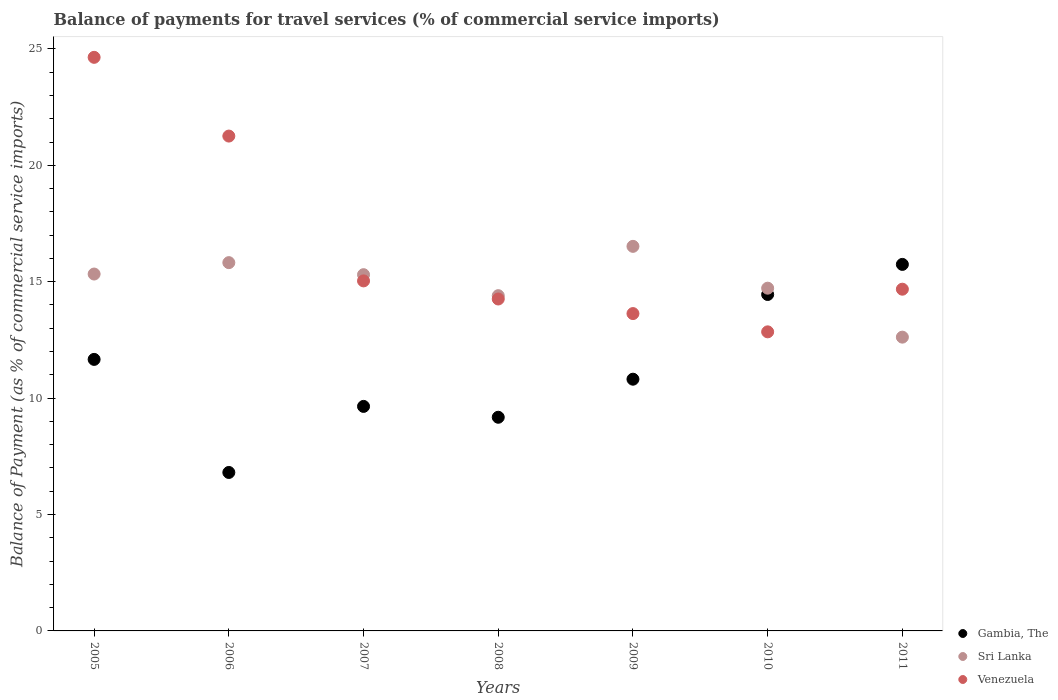Is the number of dotlines equal to the number of legend labels?
Keep it short and to the point. Yes. What is the balance of payments for travel services in Gambia, The in 2007?
Your response must be concise. 9.64. Across all years, what is the maximum balance of payments for travel services in Gambia, The?
Offer a very short reply. 15.74. Across all years, what is the minimum balance of payments for travel services in Venezuela?
Keep it short and to the point. 12.85. In which year was the balance of payments for travel services in Gambia, The maximum?
Ensure brevity in your answer.  2011. What is the total balance of payments for travel services in Venezuela in the graph?
Offer a terse response. 116.34. What is the difference between the balance of payments for travel services in Sri Lanka in 2008 and that in 2009?
Your answer should be compact. -2.12. What is the difference between the balance of payments for travel services in Gambia, The in 2006 and the balance of payments for travel services in Sri Lanka in 2010?
Your answer should be very brief. -7.92. What is the average balance of payments for travel services in Gambia, The per year?
Provide a short and direct response. 11.19. In the year 2008, what is the difference between the balance of payments for travel services in Gambia, The and balance of payments for travel services in Sri Lanka?
Keep it short and to the point. -5.22. What is the ratio of the balance of payments for travel services in Venezuela in 2007 to that in 2011?
Your response must be concise. 1.02. Is the balance of payments for travel services in Sri Lanka in 2005 less than that in 2009?
Offer a very short reply. Yes. Is the difference between the balance of payments for travel services in Gambia, The in 2007 and 2009 greater than the difference between the balance of payments for travel services in Sri Lanka in 2007 and 2009?
Your answer should be very brief. Yes. What is the difference between the highest and the second highest balance of payments for travel services in Gambia, The?
Ensure brevity in your answer.  1.29. What is the difference between the highest and the lowest balance of payments for travel services in Gambia, The?
Make the answer very short. 8.94. Does the balance of payments for travel services in Gambia, The monotonically increase over the years?
Keep it short and to the point. No. Is the balance of payments for travel services in Sri Lanka strictly greater than the balance of payments for travel services in Gambia, The over the years?
Keep it short and to the point. No. How many dotlines are there?
Your answer should be compact. 3. Does the graph contain grids?
Give a very brief answer. No. How many legend labels are there?
Offer a very short reply. 3. How are the legend labels stacked?
Give a very brief answer. Vertical. What is the title of the graph?
Provide a short and direct response. Balance of payments for travel services (% of commercial service imports). What is the label or title of the X-axis?
Your response must be concise. Years. What is the label or title of the Y-axis?
Offer a terse response. Balance of Payment (as % of commercial service imports). What is the Balance of Payment (as % of commercial service imports) in Gambia, The in 2005?
Give a very brief answer. 11.66. What is the Balance of Payment (as % of commercial service imports) in Sri Lanka in 2005?
Keep it short and to the point. 15.33. What is the Balance of Payment (as % of commercial service imports) of Venezuela in 2005?
Your answer should be compact. 24.64. What is the Balance of Payment (as % of commercial service imports) of Gambia, The in 2006?
Your answer should be compact. 6.81. What is the Balance of Payment (as % of commercial service imports) of Sri Lanka in 2006?
Offer a terse response. 15.82. What is the Balance of Payment (as % of commercial service imports) of Venezuela in 2006?
Give a very brief answer. 21.26. What is the Balance of Payment (as % of commercial service imports) in Gambia, The in 2007?
Your response must be concise. 9.64. What is the Balance of Payment (as % of commercial service imports) of Sri Lanka in 2007?
Your response must be concise. 15.3. What is the Balance of Payment (as % of commercial service imports) of Venezuela in 2007?
Give a very brief answer. 15.04. What is the Balance of Payment (as % of commercial service imports) in Gambia, The in 2008?
Keep it short and to the point. 9.18. What is the Balance of Payment (as % of commercial service imports) in Sri Lanka in 2008?
Make the answer very short. 14.4. What is the Balance of Payment (as % of commercial service imports) of Venezuela in 2008?
Your answer should be compact. 14.26. What is the Balance of Payment (as % of commercial service imports) of Gambia, The in 2009?
Your answer should be very brief. 10.81. What is the Balance of Payment (as % of commercial service imports) in Sri Lanka in 2009?
Offer a terse response. 16.52. What is the Balance of Payment (as % of commercial service imports) of Venezuela in 2009?
Your response must be concise. 13.63. What is the Balance of Payment (as % of commercial service imports) in Gambia, The in 2010?
Make the answer very short. 14.45. What is the Balance of Payment (as % of commercial service imports) in Sri Lanka in 2010?
Keep it short and to the point. 14.72. What is the Balance of Payment (as % of commercial service imports) in Venezuela in 2010?
Provide a succinct answer. 12.85. What is the Balance of Payment (as % of commercial service imports) of Gambia, The in 2011?
Make the answer very short. 15.74. What is the Balance of Payment (as % of commercial service imports) in Sri Lanka in 2011?
Your answer should be compact. 12.62. What is the Balance of Payment (as % of commercial service imports) of Venezuela in 2011?
Make the answer very short. 14.68. Across all years, what is the maximum Balance of Payment (as % of commercial service imports) in Gambia, The?
Provide a short and direct response. 15.74. Across all years, what is the maximum Balance of Payment (as % of commercial service imports) of Sri Lanka?
Your answer should be very brief. 16.52. Across all years, what is the maximum Balance of Payment (as % of commercial service imports) of Venezuela?
Your answer should be very brief. 24.64. Across all years, what is the minimum Balance of Payment (as % of commercial service imports) of Gambia, The?
Ensure brevity in your answer.  6.81. Across all years, what is the minimum Balance of Payment (as % of commercial service imports) of Sri Lanka?
Keep it short and to the point. 12.62. Across all years, what is the minimum Balance of Payment (as % of commercial service imports) in Venezuela?
Make the answer very short. 12.85. What is the total Balance of Payment (as % of commercial service imports) in Gambia, The in the graph?
Offer a terse response. 78.3. What is the total Balance of Payment (as % of commercial service imports) in Sri Lanka in the graph?
Offer a terse response. 104.71. What is the total Balance of Payment (as % of commercial service imports) in Venezuela in the graph?
Give a very brief answer. 116.34. What is the difference between the Balance of Payment (as % of commercial service imports) in Gambia, The in 2005 and that in 2006?
Provide a short and direct response. 4.86. What is the difference between the Balance of Payment (as % of commercial service imports) of Sri Lanka in 2005 and that in 2006?
Provide a short and direct response. -0.49. What is the difference between the Balance of Payment (as % of commercial service imports) of Venezuela in 2005 and that in 2006?
Your response must be concise. 3.38. What is the difference between the Balance of Payment (as % of commercial service imports) of Gambia, The in 2005 and that in 2007?
Make the answer very short. 2.02. What is the difference between the Balance of Payment (as % of commercial service imports) in Sri Lanka in 2005 and that in 2007?
Give a very brief answer. 0.03. What is the difference between the Balance of Payment (as % of commercial service imports) of Venezuela in 2005 and that in 2007?
Your answer should be very brief. 9.6. What is the difference between the Balance of Payment (as % of commercial service imports) of Gambia, The in 2005 and that in 2008?
Keep it short and to the point. 2.49. What is the difference between the Balance of Payment (as % of commercial service imports) in Sri Lanka in 2005 and that in 2008?
Your answer should be compact. 0.93. What is the difference between the Balance of Payment (as % of commercial service imports) in Venezuela in 2005 and that in 2008?
Make the answer very short. 10.38. What is the difference between the Balance of Payment (as % of commercial service imports) in Gambia, The in 2005 and that in 2009?
Offer a very short reply. 0.85. What is the difference between the Balance of Payment (as % of commercial service imports) of Sri Lanka in 2005 and that in 2009?
Your response must be concise. -1.19. What is the difference between the Balance of Payment (as % of commercial service imports) in Venezuela in 2005 and that in 2009?
Your answer should be compact. 11.01. What is the difference between the Balance of Payment (as % of commercial service imports) in Gambia, The in 2005 and that in 2010?
Provide a succinct answer. -2.79. What is the difference between the Balance of Payment (as % of commercial service imports) in Sri Lanka in 2005 and that in 2010?
Give a very brief answer. 0.61. What is the difference between the Balance of Payment (as % of commercial service imports) in Venezuela in 2005 and that in 2010?
Give a very brief answer. 11.79. What is the difference between the Balance of Payment (as % of commercial service imports) in Gambia, The in 2005 and that in 2011?
Ensure brevity in your answer.  -4.08. What is the difference between the Balance of Payment (as % of commercial service imports) in Sri Lanka in 2005 and that in 2011?
Ensure brevity in your answer.  2.71. What is the difference between the Balance of Payment (as % of commercial service imports) of Venezuela in 2005 and that in 2011?
Provide a succinct answer. 9.96. What is the difference between the Balance of Payment (as % of commercial service imports) in Gambia, The in 2006 and that in 2007?
Your answer should be compact. -2.84. What is the difference between the Balance of Payment (as % of commercial service imports) in Sri Lanka in 2006 and that in 2007?
Make the answer very short. 0.52. What is the difference between the Balance of Payment (as % of commercial service imports) of Venezuela in 2006 and that in 2007?
Offer a very short reply. 6.22. What is the difference between the Balance of Payment (as % of commercial service imports) of Gambia, The in 2006 and that in 2008?
Your answer should be compact. -2.37. What is the difference between the Balance of Payment (as % of commercial service imports) in Sri Lanka in 2006 and that in 2008?
Offer a very short reply. 1.42. What is the difference between the Balance of Payment (as % of commercial service imports) of Venezuela in 2006 and that in 2008?
Provide a succinct answer. 7. What is the difference between the Balance of Payment (as % of commercial service imports) in Gambia, The in 2006 and that in 2009?
Keep it short and to the point. -4.01. What is the difference between the Balance of Payment (as % of commercial service imports) in Sri Lanka in 2006 and that in 2009?
Ensure brevity in your answer.  -0.7. What is the difference between the Balance of Payment (as % of commercial service imports) of Venezuela in 2006 and that in 2009?
Your answer should be compact. 7.62. What is the difference between the Balance of Payment (as % of commercial service imports) in Gambia, The in 2006 and that in 2010?
Ensure brevity in your answer.  -7.64. What is the difference between the Balance of Payment (as % of commercial service imports) of Sri Lanka in 2006 and that in 2010?
Your answer should be compact. 1.1. What is the difference between the Balance of Payment (as % of commercial service imports) in Venezuela in 2006 and that in 2010?
Give a very brief answer. 8.41. What is the difference between the Balance of Payment (as % of commercial service imports) in Gambia, The in 2006 and that in 2011?
Ensure brevity in your answer.  -8.94. What is the difference between the Balance of Payment (as % of commercial service imports) in Sri Lanka in 2006 and that in 2011?
Your answer should be compact. 3.2. What is the difference between the Balance of Payment (as % of commercial service imports) in Venezuela in 2006 and that in 2011?
Keep it short and to the point. 6.58. What is the difference between the Balance of Payment (as % of commercial service imports) of Gambia, The in 2007 and that in 2008?
Ensure brevity in your answer.  0.47. What is the difference between the Balance of Payment (as % of commercial service imports) in Sri Lanka in 2007 and that in 2008?
Your answer should be very brief. 0.9. What is the difference between the Balance of Payment (as % of commercial service imports) in Venezuela in 2007 and that in 2008?
Provide a short and direct response. 0.78. What is the difference between the Balance of Payment (as % of commercial service imports) of Gambia, The in 2007 and that in 2009?
Give a very brief answer. -1.17. What is the difference between the Balance of Payment (as % of commercial service imports) of Sri Lanka in 2007 and that in 2009?
Give a very brief answer. -1.22. What is the difference between the Balance of Payment (as % of commercial service imports) of Venezuela in 2007 and that in 2009?
Provide a short and direct response. 1.4. What is the difference between the Balance of Payment (as % of commercial service imports) in Gambia, The in 2007 and that in 2010?
Your answer should be compact. -4.81. What is the difference between the Balance of Payment (as % of commercial service imports) of Sri Lanka in 2007 and that in 2010?
Offer a very short reply. 0.58. What is the difference between the Balance of Payment (as % of commercial service imports) of Venezuela in 2007 and that in 2010?
Offer a very short reply. 2.19. What is the difference between the Balance of Payment (as % of commercial service imports) of Gambia, The in 2007 and that in 2011?
Make the answer very short. -6.1. What is the difference between the Balance of Payment (as % of commercial service imports) in Sri Lanka in 2007 and that in 2011?
Provide a short and direct response. 2.68. What is the difference between the Balance of Payment (as % of commercial service imports) of Venezuela in 2007 and that in 2011?
Offer a very short reply. 0.36. What is the difference between the Balance of Payment (as % of commercial service imports) in Gambia, The in 2008 and that in 2009?
Offer a terse response. -1.64. What is the difference between the Balance of Payment (as % of commercial service imports) of Sri Lanka in 2008 and that in 2009?
Make the answer very short. -2.12. What is the difference between the Balance of Payment (as % of commercial service imports) in Venezuela in 2008 and that in 2009?
Give a very brief answer. 0.63. What is the difference between the Balance of Payment (as % of commercial service imports) in Gambia, The in 2008 and that in 2010?
Your response must be concise. -5.27. What is the difference between the Balance of Payment (as % of commercial service imports) in Sri Lanka in 2008 and that in 2010?
Provide a short and direct response. -0.32. What is the difference between the Balance of Payment (as % of commercial service imports) in Venezuela in 2008 and that in 2010?
Provide a short and direct response. 1.41. What is the difference between the Balance of Payment (as % of commercial service imports) in Gambia, The in 2008 and that in 2011?
Your response must be concise. -6.57. What is the difference between the Balance of Payment (as % of commercial service imports) of Sri Lanka in 2008 and that in 2011?
Your answer should be very brief. 1.78. What is the difference between the Balance of Payment (as % of commercial service imports) in Venezuela in 2008 and that in 2011?
Give a very brief answer. -0.42. What is the difference between the Balance of Payment (as % of commercial service imports) in Gambia, The in 2009 and that in 2010?
Make the answer very short. -3.64. What is the difference between the Balance of Payment (as % of commercial service imports) in Sri Lanka in 2009 and that in 2010?
Your answer should be very brief. 1.8. What is the difference between the Balance of Payment (as % of commercial service imports) of Venezuela in 2009 and that in 2010?
Provide a short and direct response. 0.78. What is the difference between the Balance of Payment (as % of commercial service imports) of Gambia, The in 2009 and that in 2011?
Keep it short and to the point. -4.93. What is the difference between the Balance of Payment (as % of commercial service imports) in Sri Lanka in 2009 and that in 2011?
Make the answer very short. 3.9. What is the difference between the Balance of Payment (as % of commercial service imports) of Venezuela in 2009 and that in 2011?
Offer a terse response. -1.05. What is the difference between the Balance of Payment (as % of commercial service imports) of Gambia, The in 2010 and that in 2011?
Your answer should be compact. -1.29. What is the difference between the Balance of Payment (as % of commercial service imports) of Sri Lanka in 2010 and that in 2011?
Offer a terse response. 2.1. What is the difference between the Balance of Payment (as % of commercial service imports) of Venezuela in 2010 and that in 2011?
Keep it short and to the point. -1.83. What is the difference between the Balance of Payment (as % of commercial service imports) in Gambia, The in 2005 and the Balance of Payment (as % of commercial service imports) in Sri Lanka in 2006?
Keep it short and to the point. -4.16. What is the difference between the Balance of Payment (as % of commercial service imports) in Gambia, The in 2005 and the Balance of Payment (as % of commercial service imports) in Venezuela in 2006?
Offer a very short reply. -9.59. What is the difference between the Balance of Payment (as % of commercial service imports) in Sri Lanka in 2005 and the Balance of Payment (as % of commercial service imports) in Venezuela in 2006?
Ensure brevity in your answer.  -5.93. What is the difference between the Balance of Payment (as % of commercial service imports) of Gambia, The in 2005 and the Balance of Payment (as % of commercial service imports) of Sri Lanka in 2007?
Your answer should be compact. -3.64. What is the difference between the Balance of Payment (as % of commercial service imports) of Gambia, The in 2005 and the Balance of Payment (as % of commercial service imports) of Venezuela in 2007?
Your response must be concise. -3.37. What is the difference between the Balance of Payment (as % of commercial service imports) of Sri Lanka in 2005 and the Balance of Payment (as % of commercial service imports) of Venezuela in 2007?
Provide a short and direct response. 0.29. What is the difference between the Balance of Payment (as % of commercial service imports) of Gambia, The in 2005 and the Balance of Payment (as % of commercial service imports) of Sri Lanka in 2008?
Your response must be concise. -2.74. What is the difference between the Balance of Payment (as % of commercial service imports) in Gambia, The in 2005 and the Balance of Payment (as % of commercial service imports) in Venezuela in 2008?
Give a very brief answer. -2.59. What is the difference between the Balance of Payment (as % of commercial service imports) of Sri Lanka in 2005 and the Balance of Payment (as % of commercial service imports) of Venezuela in 2008?
Your answer should be compact. 1.07. What is the difference between the Balance of Payment (as % of commercial service imports) in Gambia, The in 2005 and the Balance of Payment (as % of commercial service imports) in Sri Lanka in 2009?
Your answer should be compact. -4.86. What is the difference between the Balance of Payment (as % of commercial service imports) in Gambia, The in 2005 and the Balance of Payment (as % of commercial service imports) in Venezuela in 2009?
Keep it short and to the point. -1.97. What is the difference between the Balance of Payment (as % of commercial service imports) of Sri Lanka in 2005 and the Balance of Payment (as % of commercial service imports) of Venezuela in 2009?
Give a very brief answer. 1.7. What is the difference between the Balance of Payment (as % of commercial service imports) of Gambia, The in 2005 and the Balance of Payment (as % of commercial service imports) of Sri Lanka in 2010?
Make the answer very short. -3.06. What is the difference between the Balance of Payment (as % of commercial service imports) of Gambia, The in 2005 and the Balance of Payment (as % of commercial service imports) of Venezuela in 2010?
Provide a short and direct response. -1.18. What is the difference between the Balance of Payment (as % of commercial service imports) in Sri Lanka in 2005 and the Balance of Payment (as % of commercial service imports) in Venezuela in 2010?
Make the answer very short. 2.48. What is the difference between the Balance of Payment (as % of commercial service imports) in Gambia, The in 2005 and the Balance of Payment (as % of commercial service imports) in Sri Lanka in 2011?
Give a very brief answer. -0.96. What is the difference between the Balance of Payment (as % of commercial service imports) of Gambia, The in 2005 and the Balance of Payment (as % of commercial service imports) of Venezuela in 2011?
Give a very brief answer. -3.02. What is the difference between the Balance of Payment (as % of commercial service imports) in Sri Lanka in 2005 and the Balance of Payment (as % of commercial service imports) in Venezuela in 2011?
Keep it short and to the point. 0.65. What is the difference between the Balance of Payment (as % of commercial service imports) of Gambia, The in 2006 and the Balance of Payment (as % of commercial service imports) of Sri Lanka in 2007?
Give a very brief answer. -8.5. What is the difference between the Balance of Payment (as % of commercial service imports) of Gambia, The in 2006 and the Balance of Payment (as % of commercial service imports) of Venezuela in 2007?
Provide a succinct answer. -8.23. What is the difference between the Balance of Payment (as % of commercial service imports) in Sri Lanka in 2006 and the Balance of Payment (as % of commercial service imports) in Venezuela in 2007?
Offer a very short reply. 0.78. What is the difference between the Balance of Payment (as % of commercial service imports) of Gambia, The in 2006 and the Balance of Payment (as % of commercial service imports) of Sri Lanka in 2008?
Make the answer very short. -7.59. What is the difference between the Balance of Payment (as % of commercial service imports) of Gambia, The in 2006 and the Balance of Payment (as % of commercial service imports) of Venezuela in 2008?
Offer a very short reply. -7.45. What is the difference between the Balance of Payment (as % of commercial service imports) of Sri Lanka in 2006 and the Balance of Payment (as % of commercial service imports) of Venezuela in 2008?
Your answer should be compact. 1.56. What is the difference between the Balance of Payment (as % of commercial service imports) in Gambia, The in 2006 and the Balance of Payment (as % of commercial service imports) in Sri Lanka in 2009?
Your answer should be very brief. -9.71. What is the difference between the Balance of Payment (as % of commercial service imports) in Gambia, The in 2006 and the Balance of Payment (as % of commercial service imports) in Venezuela in 2009?
Your response must be concise. -6.82. What is the difference between the Balance of Payment (as % of commercial service imports) in Sri Lanka in 2006 and the Balance of Payment (as % of commercial service imports) in Venezuela in 2009?
Your answer should be compact. 2.19. What is the difference between the Balance of Payment (as % of commercial service imports) of Gambia, The in 2006 and the Balance of Payment (as % of commercial service imports) of Sri Lanka in 2010?
Offer a very short reply. -7.92. What is the difference between the Balance of Payment (as % of commercial service imports) in Gambia, The in 2006 and the Balance of Payment (as % of commercial service imports) in Venezuela in 2010?
Your response must be concise. -6.04. What is the difference between the Balance of Payment (as % of commercial service imports) of Sri Lanka in 2006 and the Balance of Payment (as % of commercial service imports) of Venezuela in 2010?
Keep it short and to the point. 2.97. What is the difference between the Balance of Payment (as % of commercial service imports) in Gambia, The in 2006 and the Balance of Payment (as % of commercial service imports) in Sri Lanka in 2011?
Make the answer very short. -5.81. What is the difference between the Balance of Payment (as % of commercial service imports) of Gambia, The in 2006 and the Balance of Payment (as % of commercial service imports) of Venezuela in 2011?
Keep it short and to the point. -7.87. What is the difference between the Balance of Payment (as % of commercial service imports) of Sri Lanka in 2006 and the Balance of Payment (as % of commercial service imports) of Venezuela in 2011?
Make the answer very short. 1.14. What is the difference between the Balance of Payment (as % of commercial service imports) in Gambia, The in 2007 and the Balance of Payment (as % of commercial service imports) in Sri Lanka in 2008?
Keep it short and to the point. -4.76. What is the difference between the Balance of Payment (as % of commercial service imports) of Gambia, The in 2007 and the Balance of Payment (as % of commercial service imports) of Venezuela in 2008?
Your answer should be compact. -4.61. What is the difference between the Balance of Payment (as % of commercial service imports) of Sri Lanka in 2007 and the Balance of Payment (as % of commercial service imports) of Venezuela in 2008?
Make the answer very short. 1.04. What is the difference between the Balance of Payment (as % of commercial service imports) in Gambia, The in 2007 and the Balance of Payment (as % of commercial service imports) in Sri Lanka in 2009?
Provide a short and direct response. -6.87. What is the difference between the Balance of Payment (as % of commercial service imports) of Gambia, The in 2007 and the Balance of Payment (as % of commercial service imports) of Venezuela in 2009?
Your response must be concise. -3.99. What is the difference between the Balance of Payment (as % of commercial service imports) of Sri Lanka in 2007 and the Balance of Payment (as % of commercial service imports) of Venezuela in 2009?
Your answer should be compact. 1.67. What is the difference between the Balance of Payment (as % of commercial service imports) of Gambia, The in 2007 and the Balance of Payment (as % of commercial service imports) of Sri Lanka in 2010?
Your response must be concise. -5.08. What is the difference between the Balance of Payment (as % of commercial service imports) of Gambia, The in 2007 and the Balance of Payment (as % of commercial service imports) of Venezuela in 2010?
Your response must be concise. -3.2. What is the difference between the Balance of Payment (as % of commercial service imports) in Sri Lanka in 2007 and the Balance of Payment (as % of commercial service imports) in Venezuela in 2010?
Your answer should be compact. 2.46. What is the difference between the Balance of Payment (as % of commercial service imports) of Gambia, The in 2007 and the Balance of Payment (as % of commercial service imports) of Sri Lanka in 2011?
Give a very brief answer. -2.97. What is the difference between the Balance of Payment (as % of commercial service imports) in Gambia, The in 2007 and the Balance of Payment (as % of commercial service imports) in Venezuela in 2011?
Your answer should be compact. -5.03. What is the difference between the Balance of Payment (as % of commercial service imports) of Sri Lanka in 2007 and the Balance of Payment (as % of commercial service imports) of Venezuela in 2011?
Ensure brevity in your answer.  0.62. What is the difference between the Balance of Payment (as % of commercial service imports) in Gambia, The in 2008 and the Balance of Payment (as % of commercial service imports) in Sri Lanka in 2009?
Your answer should be compact. -7.34. What is the difference between the Balance of Payment (as % of commercial service imports) in Gambia, The in 2008 and the Balance of Payment (as % of commercial service imports) in Venezuela in 2009?
Offer a terse response. -4.45. What is the difference between the Balance of Payment (as % of commercial service imports) of Sri Lanka in 2008 and the Balance of Payment (as % of commercial service imports) of Venezuela in 2009?
Ensure brevity in your answer.  0.77. What is the difference between the Balance of Payment (as % of commercial service imports) of Gambia, The in 2008 and the Balance of Payment (as % of commercial service imports) of Sri Lanka in 2010?
Offer a very short reply. -5.54. What is the difference between the Balance of Payment (as % of commercial service imports) in Gambia, The in 2008 and the Balance of Payment (as % of commercial service imports) in Venezuela in 2010?
Ensure brevity in your answer.  -3.67. What is the difference between the Balance of Payment (as % of commercial service imports) in Sri Lanka in 2008 and the Balance of Payment (as % of commercial service imports) in Venezuela in 2010?
Your response must be concise. 1.55. What is the difference between the Balance of Payment (as % of commercial service imports) in Gambia, The in 2008 and the Balance of Payment (as % of commercial service imports) in Sri Lanka in 2011?
Provide a short and direct response. -3.44. What is the difference between the Balance of Payment (as % of commercial service imports) in Gambia, The in 2008 and the Balance of Payment (as % of commercial service imports) in Venezuela in 2011?
Provide a short and direct response. -5.5. What is the difference between the Balance of Payment (as % of commercial service imports) in Sri Lanka in 2008 and the Balance of Payment (as % of commercial service imports) in Venezuela in 2011?
Offer a very short reply. -0.28. What is the difference between the Balance of Payment (as % of commercial service imports) of Gambia, The in 2009 and the Balance of Payment (as % of commercial service imports) of Sri Lanka in 2010?
Provide a succinct answer. -3.91. What is the difference between the Balance of Payment (as % of commercial service imports) in Gambia, The in 2009 and the Balance of Payment (as % of commercial service imports) in Venezuela in 2010?
Offer a very short reply. -2.03. What is the difference between the Balance of Payment (as % of commercial service imports) of Sri Lanka in 2009 and the Balance of Payment (as % of commercial service imports) of Venezuela in 2010?
Your response must be concise. 3.67. What is the difference between the Balance of Payment (as % of commercial service imports) in Gambia, The in 2009 and the Balance of Payment (as % of commercial service imports) in Sri Lanka in 2011?
Your answer should be compact. -1.81. What is the difference between the Balance of Payment (as % of commercial service imports) in Gambia, The in 2009 and the Balance of Payment (as % of commercial service imports) in Venezuela in 2011?
Ensure brevity in your answer.  -3.87. What is the difference between the Balance of Payment (as % of commercial service imports) in Sri Lanka in 2009 and the Balance of Payment (as % of commercial service imports) in Venezuela in 2011?
Ensure brevity in your answer.  1.84. What is the difference between the Balance of Payment (as % of commercial service imports) in Gambia, The in 2010 and the Balance of Payment (as % of commercial service imports) in Sri Lanka in 2011?
Offer a very short reply. 1.83. What is the difference between the Balance of Payment (as % of commercial service imports) of Gambia, The in 2010 and the Balance of Payment (as % of commercial service imports) of Venezuela in 2011?
Offer a very short reply. -0.23. What is the difference between the Balance of Payment (as % of commercial service imports) of Sri Lanka in 2010 and the Balance of Payment (as % of commercial service imports) of Venezuela in 2011?
Your answer should be compact. 0.04. What is the average Balance of Payment (as % of commercial service imports) in Gambia, The per year?
Provide a succinct answer. 11.19. What is the average Balance of Payment (as % of commercial service imports) in Sri Lanka per year?
Offer a very short reply. 14.96. What is the average Balance of Payment (as % of commercial service imports) of Venezuela per year?
Make the answer very short. 16.62. In the year 2005, what is the difference between the Balance of Payment (as % of commercial service imports) in Gambia, The and Balance of Payment (as % of commercial service imports) in Sri Lanka?
Your answer should be very brief. -3.67. In the year 2005, what is the difference between the Balance of Payment (as % of commercial service imports) of Gambia, The and Balance of Payment (as % of commercial service imports) of Venezuela?
Give a very brief answer. -12.97. In the year 2005, what is the difference between the Balance of Payment (as % of commercial service imports) of Sri Lanka and Balance of Payment (as % of commercial service imports) of Venezuela?
Provide a succinct answer. -9.31. In the year 2006, what is the difference between the Balance of Payment (as % of commercial service imports) of Gambia, The and Balance of Payment (as % of commercial service imports) of Sri Lanka?
Your response must be concise. -9.01. In the year 2006, what is the difference between the Balance of Payment (as % of commercial service imports) of Gambia, The and Balance of Payment (as % of commercial service imports) of Venezuela?
Keep it short and to the point. -14.45. In the year 2006, what is the difference between the Balance of Payment (as % of commercial service imports) in Sri Lanka and Balance of Payment (as % of commercial service imports) in Venezuela?
Offer a very short reply. -5.44. In the year 2007, what is the difference between the Balance of Payment (as % of commercial service imports) of Gambia, The and Balance of Payment (as % of commercial service imports) of Sri Lanka?
Provide a succinct answer. -5.66. In the year 2007, what is the difference between the Balance of Payment (as % of commercial service imports) in Gambia, The and Balance of Payment (as % of commercial service imports) in Venezuela?
Offer a terse response. -5.39. In the year 2007, what is the difference between the Balance of Payment (as % of commercial service imports) in Sri Lanka and Balance of Payment (as % of commercial service imports) in Venezuela?
Keep it short and to the point. 0.27. In the year 2008, what is the difference between the Balance of Payment (as % of commercial service imports) in Gambia, The and Balance of Payment (as % of commercial service imports) in Sri Lanka?
Make the answer very short. -5.22. In the year 2008, what is the difference between the Balance of Payment (as % of commercial service imports) of Gambia, The and Balance of Payment (as % of commercial service imports) of Venezuela?
Your answer should be very brief. -5.08. In the year 2008, what is the difference between the Balance of Payment (as % of commercial service imports) in Sri Lanka and Balance of Payment (as % of commercial service imports) in Venezuela?
Offer a terse response. 0.14. In the year 2009, what is the difference between the Balance of Payment (as % of commercial service imports) in Gambia, The and Balance of Payment (as % of commercial service imports) in Sri Lanka?
Give a very brief answer. -5.71. In the year 2009, what is the difference between the Balance of Payment (as % of commercial service imports) of Gambia, The and Balance of Payment (as % of commercial service imports) of Venezuela?
Ensure brevity in your answer.  -2.82. In the year 2009, what is the difference between the Balance of Payment (as % of commercial service imports) in Sri Lanka and Balance of Payment (as % of commercial service imports) in Venezuela?
Offer a terse response. 2.89. In the year 2010, what is the difference between the Balance of Payment (as % of commercial service imports) in Gambia, The and Balance of Payment (as % of commercial service imports) in Sri Lanka?
Provide a short and direct response. -0.27. In the year 2010, what is the difference between the Balance of Payment (as % of commercial service imports) in Gambia, The and Balance of Payment (as % of commercial service imports) in Venezuela?
Provide a short and direct response. 1.6. In the year 2010, what is the difference between the Balance of Payment (as % of commercial service imports) in Sri Lanka and Balance of Payment (as % of commercial service imports) in Venezuela?
Keep it short and to the point. 1.88. In the year 2011, what is the difference between the Balance of Payment (as % of commercial service imports) in Gambia, The and Balance of Payment (as % of commercial service imports) in Sri Lanka?
Ensure brevity in your answer.  3.12. In the year 2011, what is the difference between the Balance of Payment (as % of commercial service imports) in Gambia, The and Balance of Payment (as % of commercial service imports) in Venezuela?
Ensure brevity in your answer.  1.07. In the year 2011, what is the difference between the Balance of Payment (as % of commercial service imports) in Sri Lanka and Balance of Payment (as % of commercial service imports) in Venezuela?
Your answer should be compact. -2.06. What is the ratio of the Balance of Payment (as % of commercial service imports) of Gambia, The in 2005 to that in 2006?
Give a very brief answer. 1.71. What is the ratio of the Balance of Payment (as % of commercial service imports) in Venezuela in 2005 to that in 2006?
Give a very brief answer. 1.16. What is the ratio of the Balance of Payment (as % of commercial service imports) in Gambia, The in 2005 to that in 2007?
Offer a terse response. 1.21. What is the ratio of the Balance of Payment (as % of commercial service imports) in Sri Lanka in 2005 to that in 2007?
Ensure brevity in your answer.  1. What is the ratio of the Balance of Payment (as % of commercial service imports) in Venezuela in 2005 to that in 2007?
Provide a short and direct response. 1.64. What is the ratio of the Balance of Payment (as % of commercial service imports) in Gambia, The in 2005 to that in 2008?
Your response must be concise. 1.27. What is the ratio of the Balance of Payment (as % of commercial service imports) in Sri Lanka in 2005 to that in 2008?
Offer a terse response. 1.06. What is the ratio of the Balance of Payment (as % of commercial service imports) in Venezuela in 2005 to that in 2008?
Keep it short and to the point. 1.73. What is the ratio of the Balance of Payment (as % of commercial service imports) of Gambia, The in 2005 to that in 2009?
Provide a succinct answer. 1.08. What is the ratio of the Balance of Payment (as % of commercial service imports) in Sri Lanka in 2005 to that in 2009?
Ensure brevity in your answer.  0.93. What is the ratio of the Balance of Payment (as % of commercial service imports) in Venezuela in 2005 to that in 2009?
Give a very brief answer. 1.81. What is the ratio of the Balance of Payment (as % of commercial service imports) in Gambia, The in 2005 to that in 2010?
Keep it short and to the point. 0.81. What is the ratio of the Balance of Payment (as % of commercial service imports) in Sri Lanka in 2005 to that in 2010?
Your answer should be compact. 1.04. What is the ratio of the Balance of Payment (as % of commercial service imports) in Venezuela in 2005 to that in 2010?
Provide a short and direct response. 1.92. What is the ratio of the Balance of Payment (as % of commercial service imports) in Gambia, The in 2005 to that in 2011?
Your answer should be very brief. 0.74. What is the ratio of the Balance of Payment (as % of commercial service imports) in Sri Lanka in 2005 to that in 2011?
Your answer should be compact. 1.21. What is the ratio of the Balance of Payment (as % of commercial service imports) of Venezuela in 2005 to that in 2011?
Offer a terse response. 1.68. What is the ratio of the Balance of Payment (as % of commercial service imports) in Gambia, The in 2006 to that in 2007?
Make the answer very short. 0.71. What is the ratio of the Balance of Payment (as % of commercial service imports) of Sri Lanka in 2006 to that in 2007?
Provide a short and direct response. 1.03. What is the ratio of the Balance of Payment (as % of commercial service imports) of Venezuela in 2006 to that in 2007?
Provide a short and direct response. 1.41. What is the ratio of the Balance of Payment (as % of commercial service imports) in Gambia, The in 2006 to that in 2008?
Your answer should be very brief. 0.74. What is the ratio of the Balance of Payment (as % of commercial service imports) in Sri Lanka in 2006 to that in 2008?
Keep it short and to the point. 1.1. What is the ratio of the Balance of Payment (as % of commercial service imports) in Venezuela in 2006 to that in 2008?
Ensure brevity in your answer.  1.49. What is the ratio of the Balance of Payment (as % of commercial service imports) in Gambia, The in 2006 to that in 2009?
Offer a very short reply. 0.63. What is the ratio of the Balance of Payment (as % of commercial service imports) of Sri Lanka in 2006 to that in 2009?
Offer a terse response. 0.96. What is the ratio of the Balance of Payment (as % of commercial service imports) of Venezuela in 2006 to that in 2009?
Ensure brevity in your answer.  1.56. What is the ratio of the Balance of Payment (as % of commercial service imports) in Gambia, The in 2006 to that in 2010?
Keep it short and to the point. 0.47. What is the ratio of the Balance of Payment (as % of commercial service imports) in Sri Lanka in 2006 to that in 2010?
Offer a very short reply. 1.07. What is the ratio of the Balance of Payment (as % of commercial service imports) in Venezuela in 2006 to that in 2010?
Provide a succinct answer. 1.65. What is the ratio of the Balance of Payment (as % of commercial service imports) in Gambia, The in 2006 to that in 2011?
Provide a short and direct response. 0.43. What is the ratio of the Balance of Payment (as % of commercial service imports) of Sri Lanka in 2006 to that in 2011?
Give a very brief answer. 1.25. What is the ratio of the Balance of Payment (as % of commercial service imports) of Venezuela in 2006 to that in 2011?
Provide a short and direct response. 1.45. What is the ratio of the Balance of Payment (as % of commercial service imports) in Gambia, The in 2007 to that in 2008?
Offer a very short reply. 1.05. What is the ratio of the Balance of Payment (as % of commercial service imports) in Sri Lanka in 2007 to that in 2008?
Your answer should be compact. 1.06. What is the ratio of the Balance of Payment (as % of commercial service imports) in Venezuela in 2007 to that in 2008?
Your answer should be compact. 1.05. What is the ratio of the Balance of Payment (as % of commercial service imports) of Gambia, The in 2007 to that in 2009?
Provide a succinct answer. 0.89. What is the ratio of the Balance of Payment (as % of commercial service imports) in Sri Lanka in 2007 to that in 2009?
Your answer should be compact. 0.93. What is the ratio of the Balance of Payment (as % of commercial service imports) in Venezuela in 2007 to that in 2009?
Offer a terse response. 1.1. What is the ratio of the Balance of Payment (as % of commercial service imports) in Gambia, The in 2007 to that in 2010?
Give a very brief answer. 0.67. What is the ratio of the Balance of Payment (as % of commercial service imports) of Sri Lanka in 2007 to that in 2010?
Provide a short and direct response. 1.04. What is the ratio of the Balance of Payment (as % of commercial service imports) of Venezuela in 2007 to that in 2010?
Provide a short and direct response. 1.17. What is the ratio of the Balance of Payment (as % of commercial service imports) in Gambia, The in 2007 to that in 2011?
Your answer should be very brief. 0.61. What is the ratio of the Balance of Payment (as % of commercial service imports) of Sri Lanka in 2007 to that in 2011?
Offer a very short reply. 1.21. What is the ratio of the Balance of Payment (as % of commercial service imports) of Venezuela in 2007 to that in 2011?
Your answer should be very brief. 1.02. What is the ratio of the Balance of Payment (as % of commercial service imports) of Gambia, The in 2008 to that in 2009?
Your response must be concise. 0.85. What is the ratio of the Balance of Payment (as % of commercial service imports) in Sri Lanka in 2008 to that in 2009?
Offer a very short reply. 0.87. What is the ratio of the Balance of Payment (as % of commercial service imports) in Venezuela in 2008 to that in 2009?
Keep it short and to the point. 1.05. What is the ratio of the Balance of Payment (as % of commercial service imports) of Gambia, The in 2008 to that in 2010?
Provide a succinct answer. 0.64. What is the ratio of the Balance of Payment (as % of commercial service imports) in Sri Lanka in 2008 to that in 2010?
Provide a succinct answer. 0.98. What is the ratio of the Balance of Payment (as % of commercial service imports) of Venezuela in 2008 to that in 2010?
Ensure brevity in your answer.  1.11. What is the ratio of the Balance of Payment (as % of commercial service imports) in Gambia, The in 2008 to that in 2011?
Offer a very short reply. 0.58. What is the ratio of the Balance of Payment (as % of commercial service imports) in Sri Lanka in 2008 to that in 2011?
Offer a terse response. 1.14. What is the ratio of the Balance of Payment (as % of commercial service imports) of Venezuela in 2008 to that in 2011?
Offer a very short reply. 0.97. What is the ratio of the Balance of Payment (as % of commercial service imports) in Gambia, The in 2009 to that in 2010?
Keep it short and to the point. 0.75. What is the ratio of the Balance of Payment (as % of commercial service imports) in Sri Lanka in 2009 to that in 2010?
Provide a short and direct response. 1.12. What is the ratio of the Balance of Payment (as % of commercial service imports) in Venezuela in 2009 to that in 2010?
Provide a succinct answer. 1.06. What is the ratio of the Balance of Payment (as % of commercial service imports) of Gambia, The in 2009 to that in 2011?
Your response must be concise. 0.69. What is the ratio of the Balance of Payment (as % of commercial service imports) in Sri Lanka in 2009 to that in 2011?
Ensure brevity in your answer.  1.31. What is the ratio of the Balance of Payment (as % of commercial service imports) of Gambia, The in 2010 to that in 2011?
Provide a short and direct response. 0.92. What is the ratio of the Balance of Payment (as % of commercial service imports) of Sri Lanka in 2010 to that in 2011?
Keep it short and to the point. 1.17. What is the ratio of the Balance of Payment (as % of commercial service imports) of Venezuela in 2010 to that in 2011?
Your answer should be very brief. 0.88. What is the difference between the highest and the second highest Balance of Payment (as % of commercial service imports) of Gambia, The?
Provide a short and direct response. 1.29. What is the difference between the highest and the second highest Balance of Payment (as % of commercial service imports) in Sri Lanka?
Offer a very short reply. 0.7. What is the difference between the highest and the second highest Balance of Payment (as % of commercial service imports) of Venezuela?
Make the answer very short. 3.38. What is the difference between the highest and the lowest Balance of Payment (as % of commercial service imports) in Gambia, The?
Provide a short and direct response. 8.94. What is the difference between the highest and the lowest Balance of Payment (as % of commercial service imports) of Sri Lanka?
Offer a terse response. 3.9. What is the difference between the highest and the lowest Balance of Payment (as % of commercial service imports) of Venezuela?
Your answer should be very brief. 11.79. 